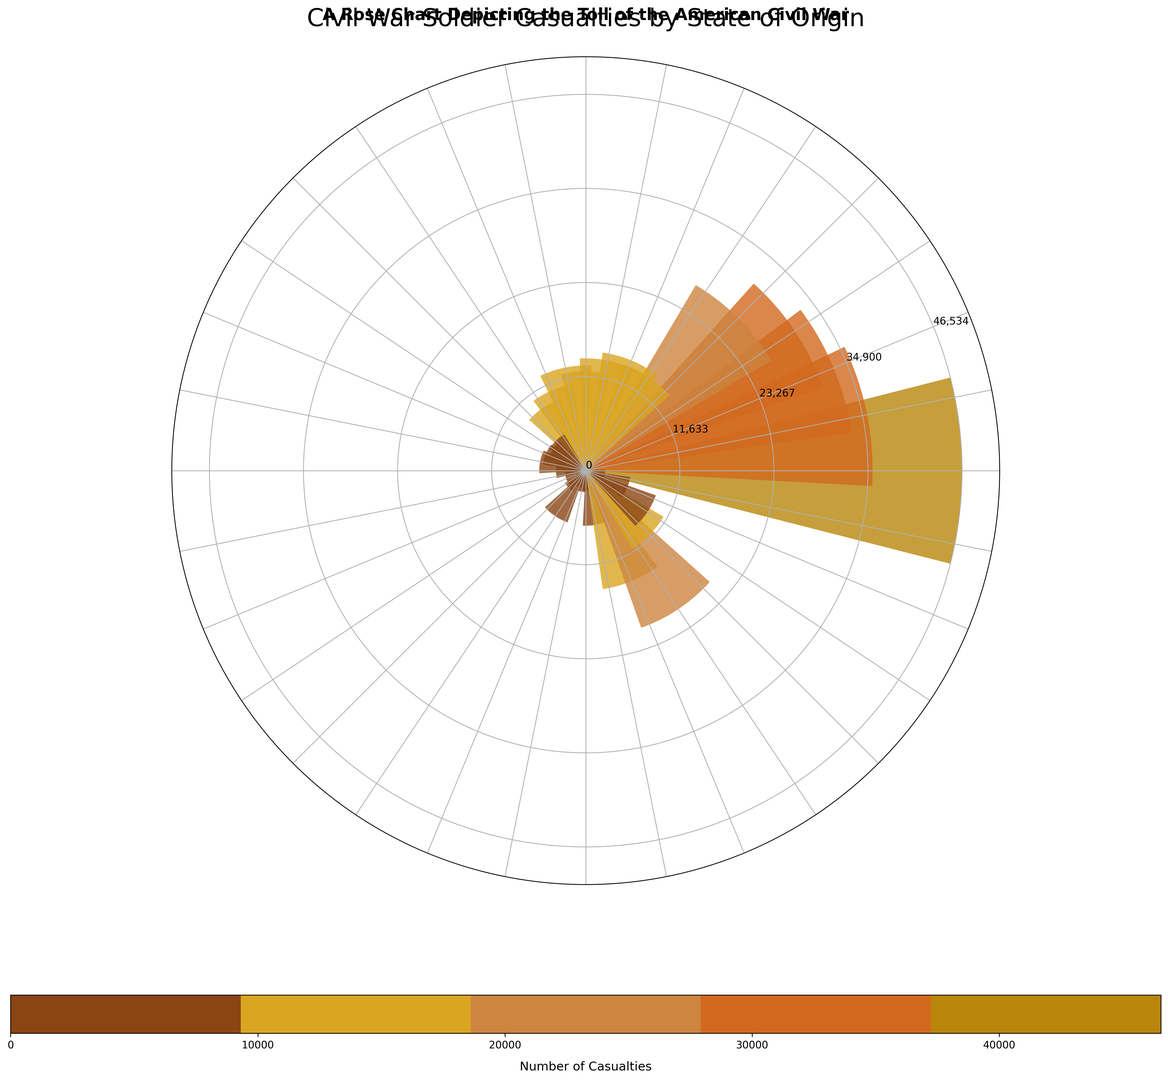Which state has the highest number of casualties? By observing the bar heights in the chart, the tallest bar represents New York, which indicates the highest number of casualties.
Answer: New York Which state has the lowest number of casualties? The shortest bar in the chart represents Rhode Island, indicating it has the lowest number of casualties.
Answer: Rhode Island What's the total number of casualties from New York, Ohio, and Pennsylvania combined? Locate the bars for New York, Ohio, and Pennsylvania and sum their casualties: 46,534 (New York) + 35,475 (Ohio) + 33,183 (Pennsylvania) = 115,192.
Answer: 115,192 Compare the casualties of Indiana and Massachusetts. Which state had more? By comparing the bar heights for Indiana and Massachusetts, Indiana's bar is higher than Massachusetts'.
Answer: Indiana How many states have casualties greater than 20,000? Identify the bars that extend higher than the 20,000 mark. There are 4 states with this characteristic: New York, Ohio, Pennsylvania, and North Carolina.
Answer: 4 Which state has more casualties, Texas or New Jersey? Compare the bar heights for Texas and New Jersey. Texas has a taller bar, indicating more casualties.
Answer: Texas What is the average number of casualties among the top three states with the highest casualties? First, identify the top three states: New York, Ohio, and Pennsylvania. Then, calculate the average: (46,534 + 35,475 + 33,183) / 3 = 38,397.33.
Answer: 38,397.33 Is there a significant color change for bars representing casualties above 30,000? Notice the color variations in the chart. Bars representing casualties above 30,000 appear to change to a darker shade from the custom colormap used.
Answer: Yes What is the difference in casualties between the states with the highest and lowest numbers? Subtract the lowest casualties (Rhode Island: 1,321) from the highest casualties (New York: 46,534) to get 46,534 - 1,321 = 45,213.
Answer: 45,213 